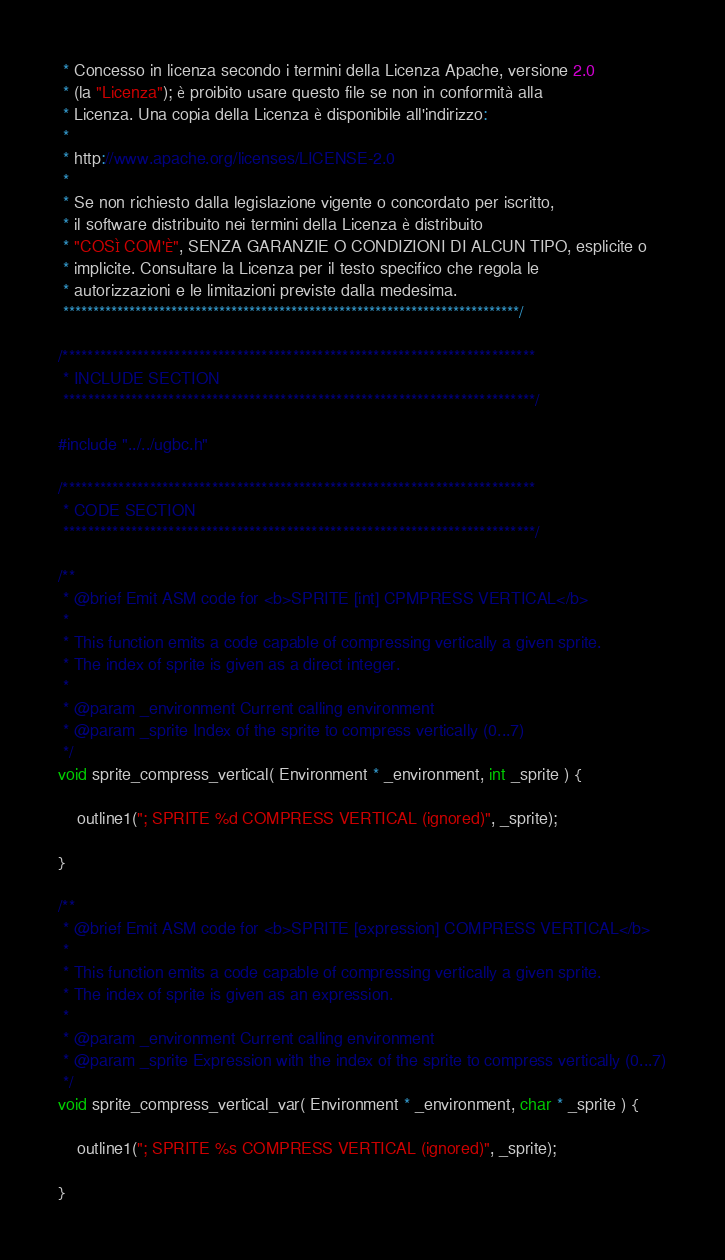<code> <loc_0><loc_0><loc_500><loc_500><_C_> * Concesso in licenza secondo i termini della Licenza Apache, versione 2.0
 * (la "Licenza"); è proibito usare questo file se non in conformità alla
 * Licenza. Una copia della Licenza è disponibile all'indirizzo:
 *
 * http://www.apache.org/licenses/LICENSE-2.0
 *
 * Se non richiesto dalla legislazione vigente o concordato per iscritto,
 * il software distribuito nei termini della Licenza è distribuito
 * "COSÌ COM'È", SENZA GARANZIE O CONDIZIONI DI ALCUN TIPO, esplicite o
 * implicite. Consultare la Licenza per il testo specifico che regola le
 * autorizzazioni e le limitazioni previste dalla medesima.
 ****************************************************************************/

/****************************************************************************
 * INCLUDE SECTION 
 ****************************************************************************/

#include "../../ugbc.h"

/****************************************************************************
 * CODE SECTION 
 ****************************************************************************/

/**
 * @brief Emit ASM code for <b>SPRITE [int] CPMPRESS VERTICAL</b>
 * 
 * This function emits a code capable of compressing vertically a given sprite.
 * The index of sprite is given as a direct integer.
 * 
 * @param _environment Current calling environment
 * @param _sprite Index of the sprite to compress vertically (0...7)
 */
void sprite_compress_vertical( Environment * _environment, int _sprite ) {

    outline1("; SPRITE %d COMPRESS VERTICAL (ignored)", _sprite);

}

/**
 * @brief Emit ASM code for <b>SPRITE [expression] COMPRESS VERTICAL</b>
 * 
 * This function emits a code capable of compressing vertically a given sprite.
 * The index of sprite is given as an expression.
 * 
 * @param _environment Current calling environment
 * @param _sprite Expression with the index of the sprite to compress vertically (0...7)
 */
void sprite_compress_vertical_var( Environment * _environment, char * _sprite ) {

    outline1("; SPRITE %s COMPRESS VERTICAL (ignored)", _sprite);

}
</code> 